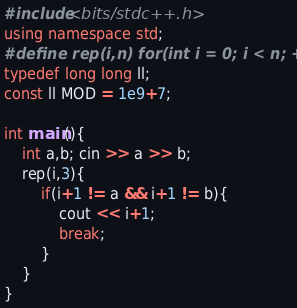<code> <loc_0><loc_0><loc_500><loc_500><_C++_>#include<bits/stdc++.h>
using namespace std;
#define rep(i,n) for(int i = 0; i < n; ++i)
typedef long long ll;
const ll MOD = 1e9+7;

int main(){
    int a,b; cin >> a >> b;
    rep(i,3){
        if(i+1 != a && i+1 != b){
            cout << i+1;
            break;
        }
    }
}</code> 